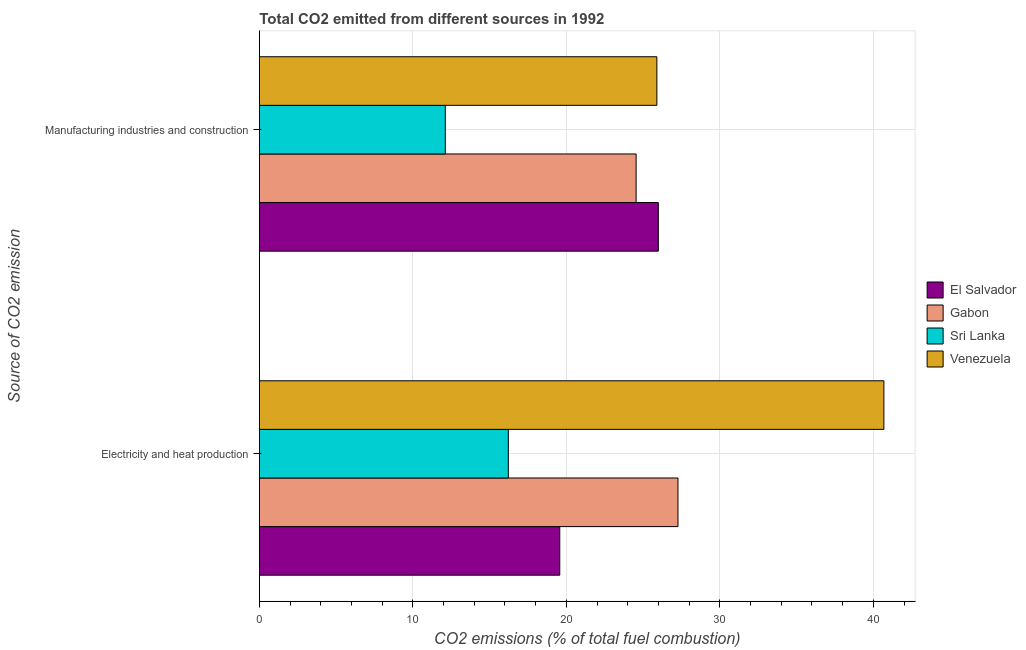How many different coloured bars are there?
Make the answer very short. 4. How many groups of bars are there?
Provide a short and direct response. 2. Are the number of bars per tick equal to the number of legend labels?
Your answer should be compact. Yes. How many bars are there on the 1st tick from the bottom?
Your answer should be compact. 4. What is the label of the 2nd group of bars from the top?
Your answer should be very brief. Electricity and heat production. What is the co2 emissions due to electricity and heat production in Sri Lanka?
Provide a succinct answer. 16.22. Across all countries, what is the maximum co2 emissions due to manufacturing industries?
Keep it short and to the point. 25.99. Across all countries, what is the minimum co2 emissions due to electricity and heat production?
Offer a very short reply. 16.22. In which country was the co2 emissions due to electricity and heat production maximum?
Make the answer very short. Venezuela. In which country was the co2 emissions due to manufacturing industries minimum?
Offer a terse response. Sri Lanka. What is the total co2 emissions due to manufacturing industries in the graph?
Keep it short and to the point. 88.55. What is the difference between the co2 emissions due to manufacturing industries in El Salvador and that in Sri Lanka?
Offer a very short reply. 13.88. What is the difference between the co2 emissions due to manufacturing industries in Sri Lanka and the co2 emissions due to electricity and heat production in El Salvador?
Provide a short and direct response. -7.46. What is the average co2 emissions due to manufacturing industries per country?
Provide a short and direct response. 22.14. What is the difference between the co2 emissions due to manufacturing industries and co2 emissions due to electricity and heat production in Gabon?
Provide a short and direct response. -2.73. What is the ratio of the co2 emissions due to electricity and heat production in Gabon to that in Venezuela?
Your answer should be compact. 0.67. What does the 3rd bar from the top in Electricity and heat production represents?
Provide a succinct answer. Gabon. What does the 4th bar from the bottom in Manufacturing industries and construction represents?
Provide a short and direct response. Venezuela. Are all the bars in the graph horizontal?
Your answer should be very brief. Yes. How many countries are there in the graph?
Your answer should be compact. 4. What is the difference between two consecutive major ticks on the X-axis?
Your answer should be compact. 10. Does the graph contain any zero values?
Keep it short and to the point. No. How are the legend labels stacked?
Give a very brief answer. Vertical. What is the title of the graph?
Your answer should be very brief. Total CO2 emitted from different sources in 1992. Does "Euro area" appear as one of the legend labels in the graph?
Your response must be concise. No. What is the label or title of the X-axis?
Make the answer very short. CO2 emissions (% of total fuel combustion). What is the label or title of the Y-axis?
Your response must be concise. Source of CO2 emission. What is the CO2 emissions (% of total fuel combustion) in El Salvador in Electricity and heat production?
Provide a short and direct response. 19.57. What is the CO2 emissions (% of total fuel combustion) in Gabon in Electricity and heat production?
Offer a very short reply. 27.27. What is the CO2 emissions (% of total fuel combustion) in Sri Lanka in Electricity and heat production?
Give a very brief answer. 16.22. What is the CO2 emissions (% of total fuel combustion) in Venezuela in Electricity and heat production?
Your response must be concise. 40.69. What is the CO2 emissions (% of total fuel combustion) in El Salvador in Manufacturing industries and construction?
Your answer should be compact. 25.99. What is the CO2 emissions (% of total fuel combustion) of Gabon in Manufacturing industries and construction?
Give a very brief answer. 24.55. What is the CO2 emissions (% of total fuel combustion) of Sri Lanka in Manufacturing industries and construction?
Offer a terse response. 12.11. What is the CO2 emissions (% of total fuel combustion) in Venezuela in Manufacturing industries and construction?
Offer a very short reply. 25.9. Across all Source of CO2 emission, what is the maximum CO2 emissions (% of total fuel combustion) in El Salvador?
Keep it short and to the point. 25.99. Across all Source of CO2 emission, what is the maximum CO2 emissions (% of total fuel combustion) in Gabon?
Provide a short and direct response. 27.27. Across all Source of CO2 emission, what is the maximum CO2 emissions (% of total fuel combustion) of Sri Lanka?
Keep it short and to the point. 16.22. Across all Source of CO2 emission, what is the maximum CO2 emissions (% of total fuel combustion) in Venezuela?
Give a very brief answer. 40.69. Across all Source of CO2 emission, what is the minimum CO2 emissions (% of total fuel combustion) of El Salvador?
Your response must be concise. 19.57. Across all Source of CO2 emission, what is the minimum CO2 emissions (% of total fuel combustion) of Gabon?
Offer a very short reply. 24.55. Across all Source of CO2 emission, what is the minimum CO2 emissions (% of total fuel combustion) of Sri Lanka?
Your response must be concise. 12.11. Across all Source of CO2 emission, what is the minimum CO2 emissions (% of total fuel combustion) of Venezuela?
Your answer should be compact. 25.9. What is the total CO2 emissions (% of total fuel combustion) of El Salvador in the graph?
Give a very brief answer. 45.57. What is the total CO2 emissions (% of total fuel combustion) of Gabon in the graph?
Your response must be concise. 51.82. What is the total CO2 emissions (% of total fuel combustion) of Sri Lanka in the graph?
Ensure brevity in your answer.  28.34. What is the total CO2 emissions (% of total fuel combustion) of Venezuela in the graph?
Make the answer very short. 66.58. What is the difference between the CO2 emissions (% of total fuel combustion) in El Salvador in Electricity and heat production and that in Manufacturing industries and construction?
Give a very brief answer. -6.42. What is the difference between the CO2 emissions (% of total fuel combustion) in Gabon in Electricity and heat production and that in Manufacturing industries and construction?
Ensure brevity in your answer.  2.73. What is the difference between the CO2 emissions (% of total fuel combustion) in Sri Lanka in Electricity and heat production and that in Manufacturing industries and construction?
Your answer should be very brief. 4.11. What is the difference between the CO2 emissions (% of total fuel combustion) of Venezuela in Electricity and heat production and that in Manufacturing industries and construction?
Offer a terse response. 14.79. What is the difference between the CO2 emissions (% of total fuel combustion) of El Salvador in Electricity and heat production and the CO2 emissions (% of total fuel combustion) of Gabon in Manufacturing industries and construction?
Your answer should be very brief. -4.97. What is the difference between the CO2 emissions (% of total fuel combustion) in El Salvador in Electricity and heat production and the CO2 emissions (% of total fuel combustion) in Sri Lanka in Manufacturing industries and construction?
Keep it short and to the point. 7.46. What is the difference between the CO2 emissions (% of total fuel combustion) of El Salvador in Electricity and heat production and the CO2 emissions (% of total fuel combustion) of Venezuela in Manufacturing industries and construction?
Your response must be concise. -6.33. What is the difference between the CO2 emissions (% of total fuel combustion) in Gabon in Electricity and heat production and the CO2 emissions (% of total fuel combustion) in Sri Lanka in Manufacturing industries and construction?
Your answer should be compact. 15.16. What is the difference between the CO2 emissions (% of total fuel combustion) of Gabon in Electricity and heat production and the CO2 emissions (% of total fuel combustion) of Venezuela in Manufacturing industries and construction?
Keep it short and to the point. 1.38. What is the difference between the CO2 emissions (% of total fuel combustion) of Sri Lanka in Electricity and heat production and the CO2 emissions (% of total fuel combustion) of Venezuela in Manufacturing industries and construction?
Offer a terse response. -9.68. What is the average CO2 emissions (% of total fuel combustion) of El Salvador per Source of CO2 emission?
Provide a short and direct response. 22.78. What is the average CO2 emissions (% of total fuel combustion) in Gabon per Source of CO2 emission?
Your answer should be compact. 25.91. What is the average CO2 emissions (% of total fuel combustion) in Sri Lanka per Source of CO2 emission?
Your response must be concise. 14.17. What is the average CO2 emissions (% of total fuel combustion) in Venezuela per Source of CO2 emission?
Make the answer very short. 33.29. What is the difference between the CO2 emissions (% of total fuel combustion) of El Salvador and CO2 emissions (% of total fuel combustion) of Gabon in Electricity and heat production?
Give a very brief answer. -7.7. What is the difference between the CO2 emissions (% of total fuel combustion) in El Salvador and CO2 emissions (% of total fuel combustion) in Sri Lanka in Electricity and heat production?
Keep it short and to the point. 3.35. What is the difference between the CO2 emissions (% of total fuel combustion) in El Salvador and CO2 emissions (% of total fuel combustion) in Venezuela in Electricity and heat production?
Provide a short and direct response. -21.12. What is the difference between the CO2 emissions (% of total fuel combustion) in Gabon and CO2 emissions (% of total fuel combustion) in Sri Lanka in Electricity and heat production?
Give a very brief answer. 11.05. What is the difference between the CO2 emissions (% of total fuel combustion) of Gabon and CO2 emissions (% of total fuel combustion) of Venezuela in Electricity and heat production?
Offer a very short reply. -13.41. What is the difference between the CO2 emissions (% of total fuel combustion) in Sri Lanka and CO2 emissions (% of total fuel combustion) in Venezuela in Electricity and heat production?
Your answer should be very brief. -24.47. What is the difference between the CO2 emissions (% of total fuel combustion) in El Salvador and CO2 emissions (% of total fuel combustion) in Gabon in Manufacturing industries and construction?
Your answer should be very brief. 1.45. What is the difference between the CO2 emissions (% of total fuel combustion) in El Salvador and CO2 emissions (% of total fuel combustion) in Sri Lanka in Manufacturing industries and construction?
Provide a short and direct response. 13.88. What is the difference between the CO2 emissions (% of total fuel combustion) in El Salvador and CO2 emissions (% of total fuel combustion) in Venezuela in Manufacturing industries and construction?
Provide a short and direct response. 0.1. What is the difference between the CO2 emissions (% of total fuel combustion) in Gabon and CO2 emissions (% of total fuel combustion) in Sri Lanka in Manufacturing industries and construction?
Your answer should be very brief. 12.43. What is the difference between the CO2 emissions (% of total fuel combustion) in Gabon and CO2 emissions (% of total fuel combustion) in Venezuela in Manufacturing industries and construction?
Offer a terse response. -1.35. What is the difference between the CO2 emissions (% of total fuel combustion) of Sri Lanka and CO2 emissions (% of total fuel combustion) of Venezuela in Manufacturing industries and construction?
Your response must be concise. -13.78. What is the ratio of the CO2 emissions (% of total fuel combustion) in El Salvador in Electricity and heat production to that in Manufacturing industries and construction?
Give a very brief answer. 0.75. What is the ratio of the CO2 emissions (% of total fuel combustion) of Sri Lanka in Electricity and heat production to that in Manufacturing industries and construction?
Provide a succinct answer. 1.34. What is the ratio of the CO2 emissions (% of total fuel combustion) in Venezuela in Electricity and heat production to that in Manufacturing industries and construction?
Offer a very short reply. 1.57. What is the difference between the highest and the second highest CO2 emissions (% of total fuel combustion) in El Salvador?
Your answer should be compact. 6.42. What is the difference between the highest and the second highest CO2 emissions (% of total fuel combustion) in Gabon?
Your answer should be very brief. 2.73. What is the difference between the highest and the second highest CO2 emissions (% of total fuel combustion) of Sri Lanka?
Offer a terse response. 4.11. What is the difference between the highest and the second highest CO2 emissions (% of total fuel combustion) in Venezuela?
Your answer should be very brief. 14.79. What is the difference between the highest and the lowest CO2 emissions (% of total fuel combustion) in El Salvador?
Give a very brief answer. 6.42. What is the difference between the highest and the lowest CO2 emissions (% of total fuel combustion) in Gabon?
Your answer should be very brief. 2.73. What is the difference between the highest and the lowest CO2 emissions (% of total fuel combustion) in Sri Lanka?
Offer a terse response. 4.11. What is the difference between the highest and the lowest CO2 emissions (% of total fuel combustion) in Venezuela?
Keep it short and to the point. 14.79. 